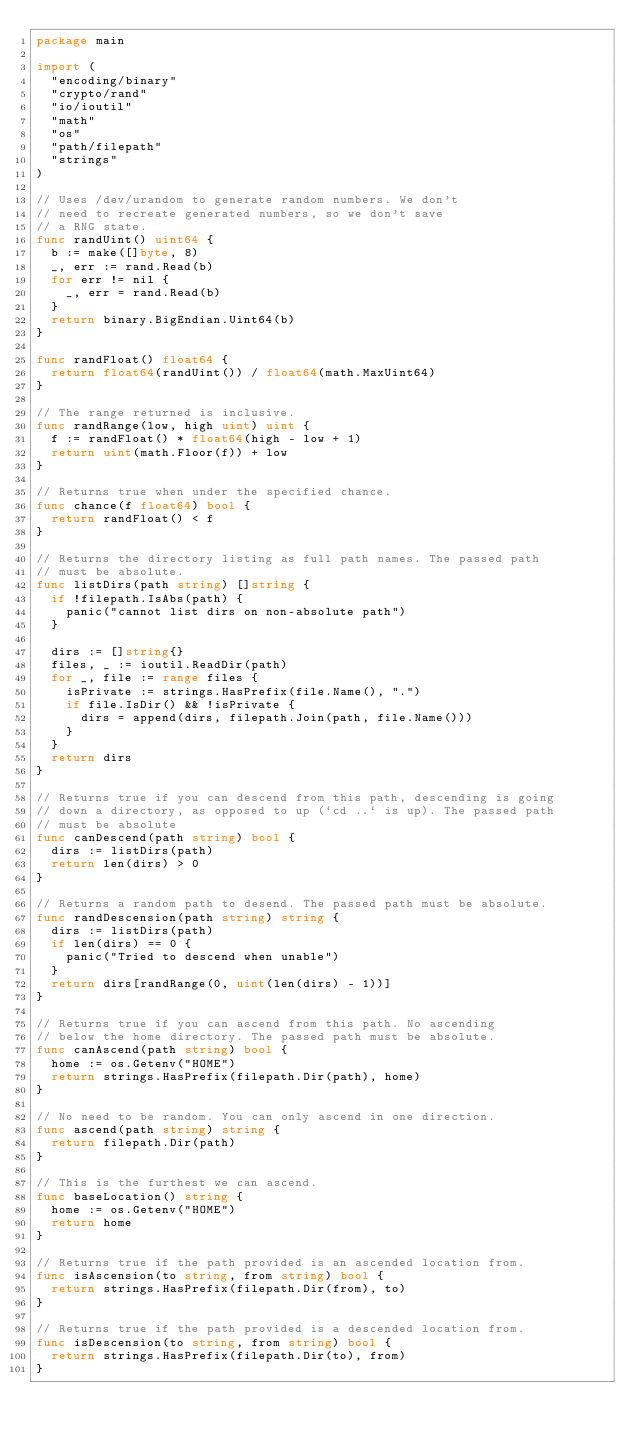<code> <loc_0><loc_0><loc_500><loc_500><_Go_>package main

import (
	"encoding/binary"
	"crypto/rand"
	"io/ioutil"
	"math"
	"os"
	"path/filepath"
	"strings"
)

// Uses /dev/urandom to generate random numbers. We don't
// need to recreate generated numbers, so we don't save
// a RNG state.
func randUint() uint64 {
	b := make([]byte, 8)
	_, err := rand.Read(b)
	for err != nil {
		_, err = rand.Read(b)
	}
	return binary.BigEndian.Uint64(b)
}

func randFloat() float64 {
	return float64(randUint()) / float64(math.MaxUint64)
}

// The range returned is inclusive.
func randRange(low, high uint) uint {
	f := randFloat() * float64(high - low + 1)
	return uint(math.Floor(f)) + low
}

// Returns true when under the specified chance.
func chance(f float64) bool {
	return randFloat() < f
}

// Returns the directory listing as full path names. The passed path
// must be absolute.
func listDirs(path string) []string {
	if !filepath.IsAbs(path) {
		panic("cannot list dirs on non-absolute path")
	}

	dirs := []string{}
	files, _ := ioutil.ReadDir(path)
	for _, file := range files {
		isPrivate := strings.HasPrefix(file.Name(), ".")
		if file.IsDir() && !isPrivate {
			dirs = append(dirs, filepath.Join(path, file.Name()))
		}
	}
	return dirs
}

// Returns true if you can descend from this path, descending is going
// down a directory, as opposed to up (`cd ..` is up). The passed path
// must be absolute
func canDescend(path string) bool {
	dirs := listDirs(path)
	return len(dirs) > 0
}

// Returns a random path to desend. The passed path must be absolute.
func randDescension(path string) string {
	dirs := listDirs(path)
	if len(dirs) == 0 {
		panic("Tried to descend when unable")
	}
	return dirs[randRange(0, uint(len(dirs) - 1))]
}

// Returns true if you can ascend from this path. No ascending
// below the home directory. The passed path must be absolute.
func canAscend(path string) bool {
	home := os.Getenv("HOME")
	return strings.HasPrefix(filepath.Dir(path), home)
}

// No need to be random. You can only ascend in one direction.
func ascend(path string) string {
	return filepath.Dir(path)
}

// This is the furthest we can ascend.
func baseLocation() string {
	home := os.Getenv("HOME")
	return home
}

// Returns true if the path provided is an ascended location from.
func isAscension(to string, from string) bool {
	return strings.HasPrefix(filepath.Dir(from), to)
}

// Returns true if the path provided is a descended location from.
func isDescension(to string, from string) bool {
	return strings.HasPrefix(filepath.Dir(to), from)
}
</code> 